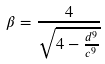<formula> <loc_0><loc_0><loc_500><loc_500>\beta = \frac { 4 } { \sqrt { 4 - \frac { d ^ { 9 } } { c ^ { 9 } } } }</formula> 